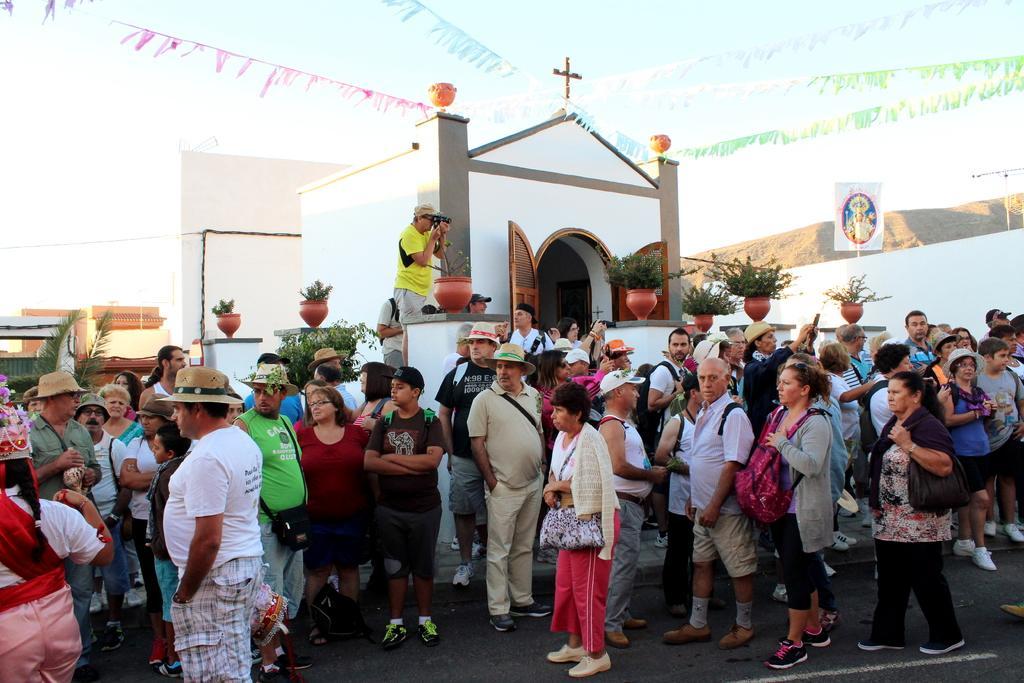Describe this image in one or two sentences. At the bottom of this image, there are persons in different color dresses. Some of them are on the road. In the background, there are potted plants on the pillars, there is a person holding a camera, there are buildings, decorative papers attached to the threads, a wall, a mountain, a tree and there are clouds in the blue sky. 